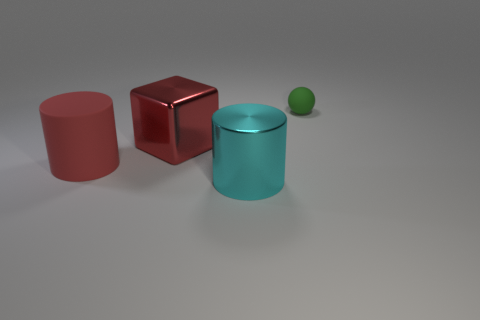What is the material of the red cube that is to the right of the matte thing on the left side of the large cylinder to the right of the matte cylinder?
Offer a terse response. Metal. What is the shape of the big thing that is made of the same material as the block?
Ensure brevity in your answer.  Cylinder. Is there any other thing of the same color as the big shiny cylinder?
Provide a short and direct response. No. There is a big cylinder on the right side of the metal object that is behind the big cyan metallic cylinder; how many objects are on the left side of it?
Give a very brief answer. 2. What number of gray objects are either spheres or shiny cylinders?
Give a very brief answer. 0. There is a red rubber cylinder; is its size the same as the thing that is in front of the red cylinder?
Offer a very short reply. Yes. There is a big red thing that is the same shape as the large cyan metal thing; what is its material?
Provide a short and direct response. Rubber. How many other objects are there of the same size as the green object?
Provide a short and direct response. 0. What shape is the rubber thing that is right of the large rubber cylinder that is left of the metallic thing on the left side of the large cyan metal cylinder?
Give a very brief answer. Sphere. The object that is on the left side of the ball and behind the big red rubber cylinder has what shape?
Offer a very short reply. Cube. 